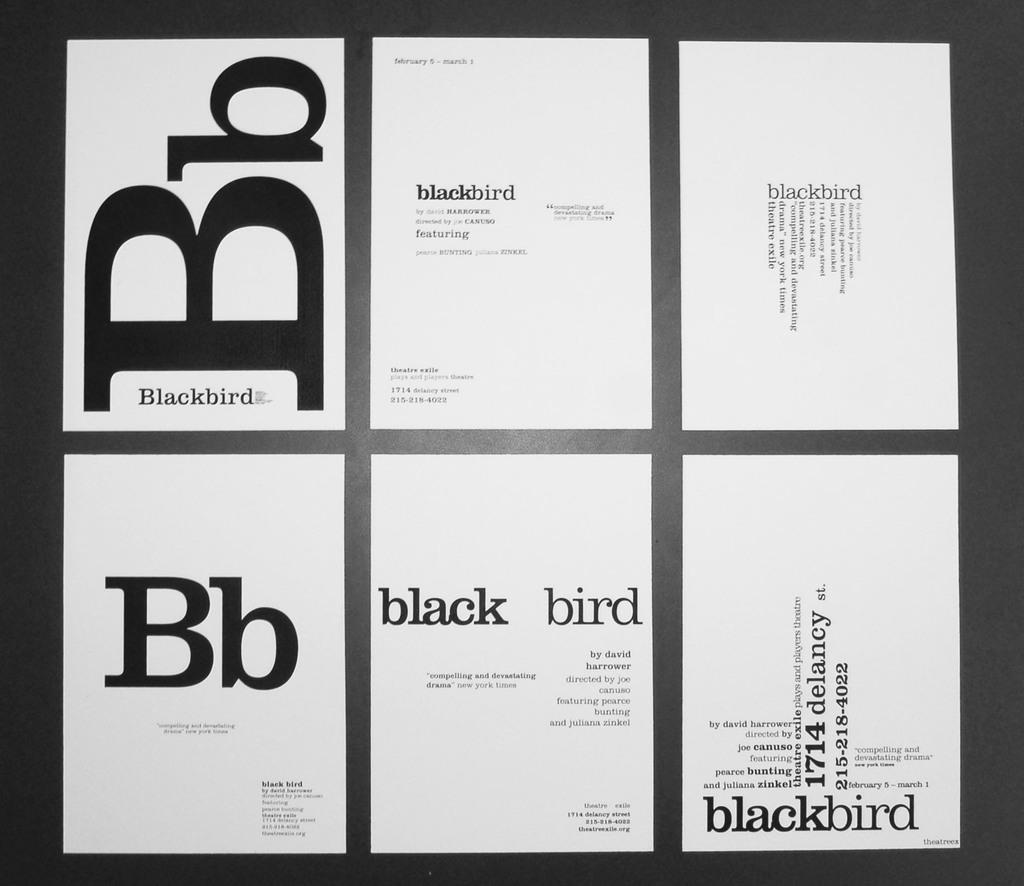<image>
Write a terse but informative summary of the picture. a few sheets of paper with the letters Bb next to each other 